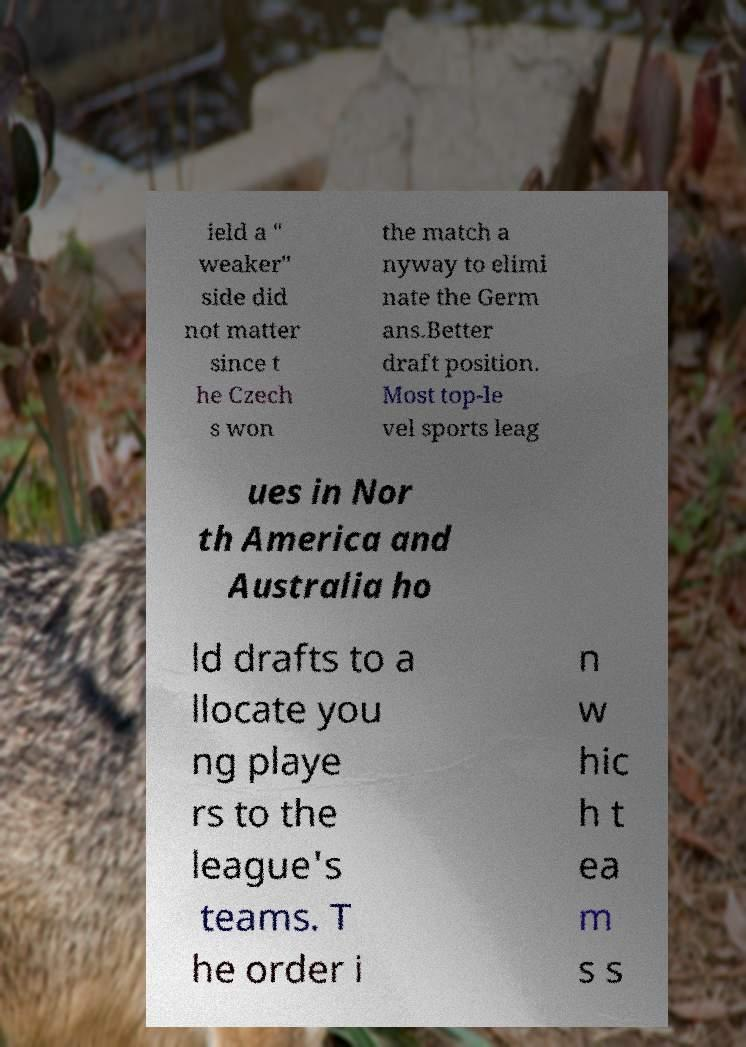Could you assist in decoding the text presented in this image and type it out clearly? ield a " weaker" side did not matter since t he Czech s won the match a nyway to elimi nate the Germ ans.Better draft position. Most top-le vel sports leag ues in Nor th America and Australia ho ld drafts to a llocate you ng playe rs to the league's teams. T he order i n w hic h t ea m s s 